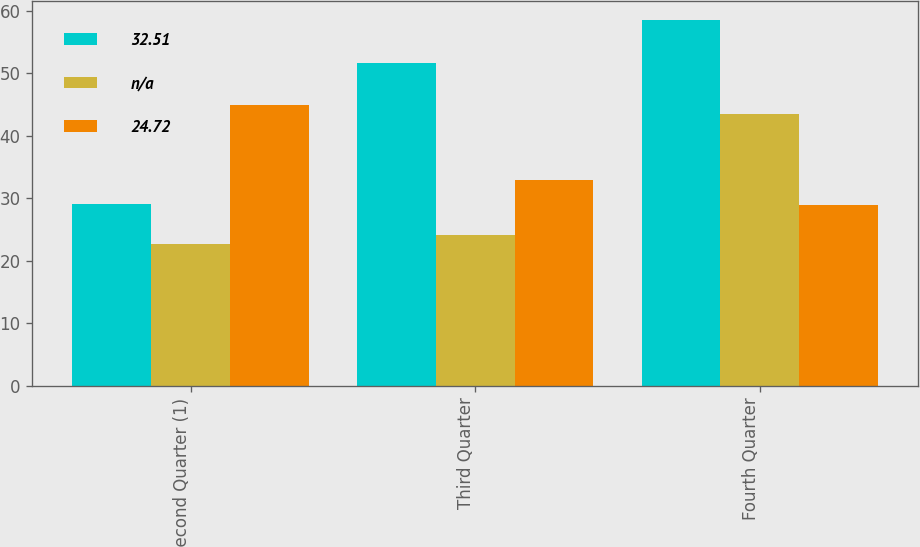Convert chart. <chart><loc_0><loc_0><loc_500><loc_500><stacked_bar_chart><ecel><fcel>Second Quarter (1)<fcel>Third Quarter<fcel>Fourth Quarter<nl><fcel>32.51<fcel>29.07<fcel>51.6<fcel>58.58<nl><fcel>nan<fcel>22.67<fcel>24.15<fcel>43.55<nl><fcel>24.72<fcel>45<fcel>32.88<fcel>28.88<nl></chart> 